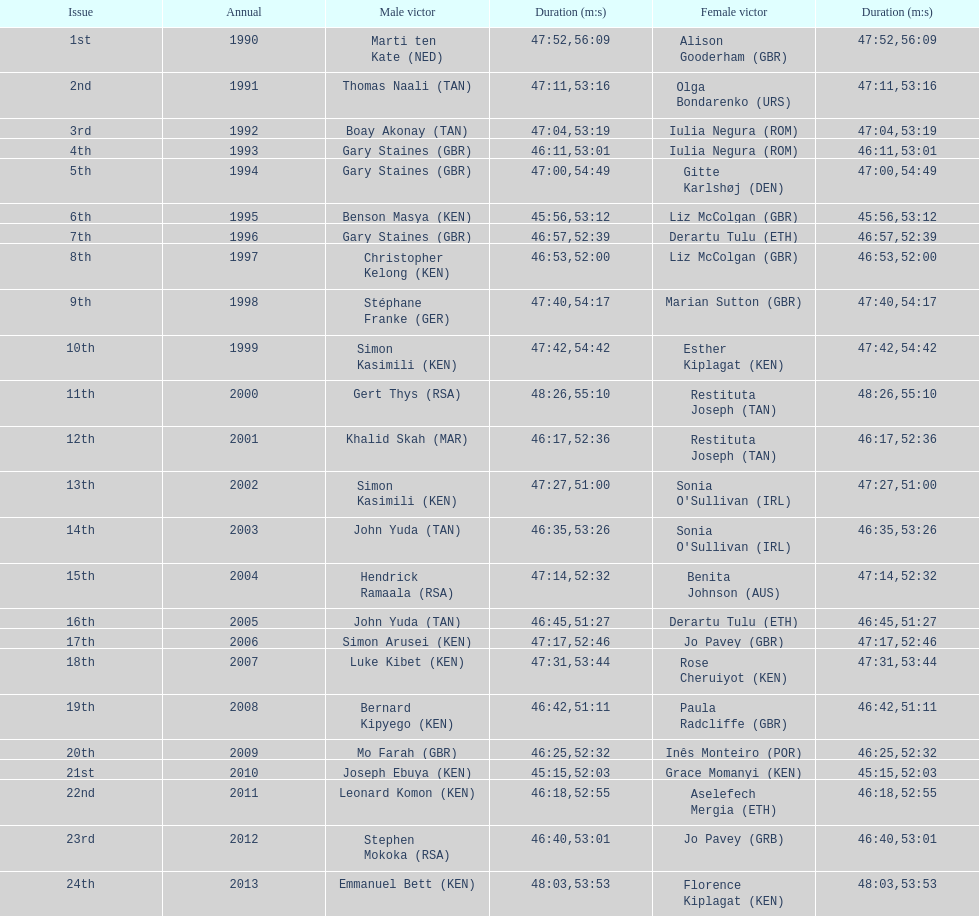Help me parse the entirety of this table. {'header': ['Issue', 'Annual', 'Male victor', 'Duration (m:s)', 'Female victor', 'Duration (m:s)'], 'rows': [['1st', '1990', 'Marti ten Kate\xa0(NED)', '47:52', 'Alison Gooderham\xa0(GBR)', '56:09'], ['2nd', '1991', 'Thomas Naali\xa0(TAN)', '47:11', 'Olga Bondarenko\xa0(URS)', '53:16'], ['3rd', '1992', 'Boay Akonay\xa0(TAN)', '47:04', 'Iulia Negura\xa0(ROM)', '53:19'], ['4th', '1993', 'Gary Staines\xa0(GBR)', '46:11', 'Iulia Negura\xa0(ROM)', '53:01'], ['5th', '1994', 'Gary Staines\xa0(GBR)', '47:00', 'Gitte Karlshøj\xa0(DEN)', '54:49'], ['6th', '1995', 'Benson Masya\xa0(KEN)', '45:56', 'Liz McColgan\xa0(GBR)', '53:12'], ['7th', '1996', 'Gary Staines\xa0(GBR)', '46:57', 'Derartu Tulu\xa0(ETH)', '52:39'], ['8th', '1997', 'Christopher Kelong\xa0(KEN)', '46:53', 'Liz McColgan\xa0(GBR)', '52:00'], ['9th', '1998', 'Stéphane Franke\xa0(GER)', '47:40', 'Marian Sutton\xa0(GBR)', '54:17'], ['10th', '1999', 'Simon Kasimili\xa0(KEN)', '47:42', 'Esther Kiplagat\xa0(KEN)', '54:42'], ['11th', '2000', 'Gert Thys\xa0(RSA)', '48:26', 'Restituta Joseph\xa0(TAN)', '55:10'], ['12th', '2001', 'Khalid Skah\xa0(MAR)', '46:17', 'Restituta Joseph\xa0(TAN)', '52:36'], ['13th', '2002', 'Simon Kasimili\xa0(KEN)', '47:27', "Sonia O'Sullivan\xa0(IRL)", '51:00'], ['14th', '2003', 'John Yuda\xa0(TAN)', '46:35', "Sonia O'Sullivan\xa0(IRL)", '53:26'], ['15th', '2004', 'Hendrick Ramaala\xa0(RSA)', '47:14', 'Benita Johnson\xa0(AUS)', '52:32'], ['16th', '2005', 'John Yuda\xa0(TAN)', '46:45', 'Derartu Tulu\xa0(ETH)', '51:27'], ['17th', '2006', 'Simon Arusei\xa0(KEN)', '47:17', 'Jo Pavey\xa0(GBR)', '52:46'], ['18th', '2007', 'Luke Kibet\xa0(KEN)', '47:31', 'Rose Cheruiyot\xa0(KEN)', '53:44'], ['19th', '2008', 'Bernard Kipyego\xa0(KEN)', '46:42', 'Paula Radcliffe\xa0(GBR)', '51:11'], ['20th', '2009', 'Mo Farah\xa0(GBR)', '46:25', 'Inês Monteiro\xa0(POR)', '52:32'], ['21st', '2010', 'Joseph Ebuya\xa0(KEN)', '45:15', 'Grace Momanyi\xa0(KEN)', '52:03'], ['22nd', '2011', 'Leonard Komon\xa0(KEN)', '46:18', 'Aselefech Mergia\xa0(ETH)', '52:55'], ['23rd', '2012', 'Stephen Mokoka\xa0(RSA)', '46:40', 'Jo Pavey\xa0(GRB)', '53:01'], ['24th', '2013', 'Emmanuel Bett\xa0(KEN)', '48:03', 'Florence Kiplagat\xa0(KEN)', '53:53']]} Where any women faster than any men? No. 